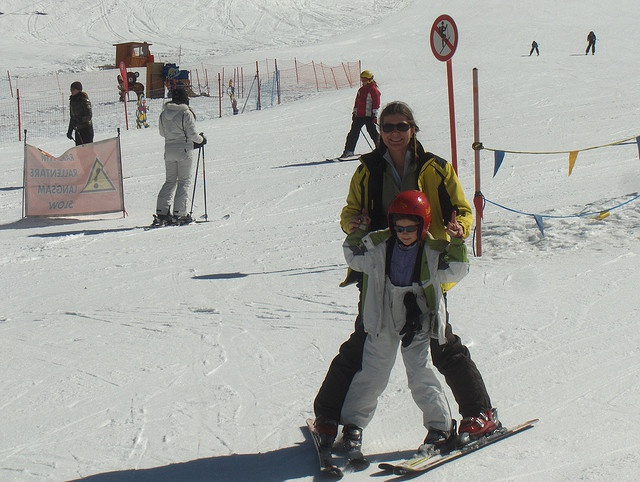Describe the objects in this image and their specific colors. I can see people in lightgray, gray, black, darkgray, and maroon tones, people in lightgray, black, olive, maroon, and gray tones, people in lightgray, gray, darkgray, and black tones, skis in lightgray, black, gray, and darkgray tones, and people in lightgray, black, maroon, and gray tones in this image. 